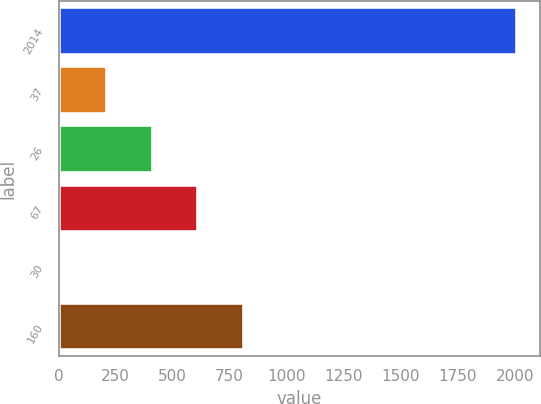<chart> <loc_0><loc_0><loc_500><loc_500><bar_chart><fcel>2014<fcel>37<fcel>26<fcel>67<fcel>30<fcel>160<nl><fcel>2012<fcel>213.8<fcel>413.6<fcel>613.4<fcel>14<fcel>813.2<nl></chart> 